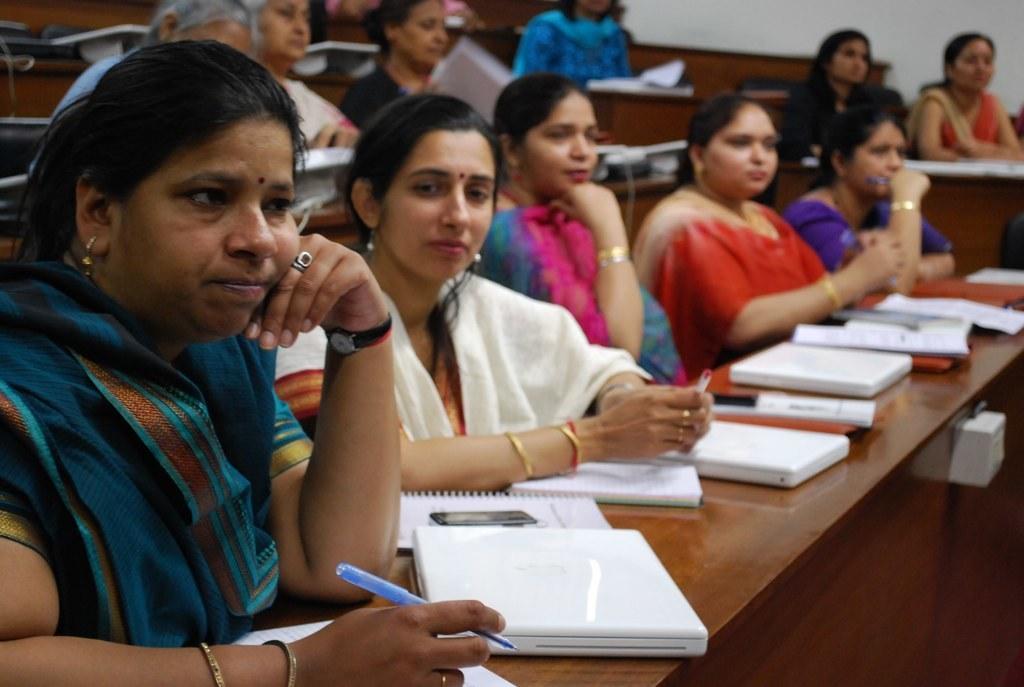Describe this image in one or two sentences. In this picture we can see a group of people sitting. In front of the people, there are wooden tables and on the tables there are books. There are three women holding the pens. At the top right corner of the image, there is a wall. On the right side of the image, it looks like a switchboard which is attached to a wooden table. 